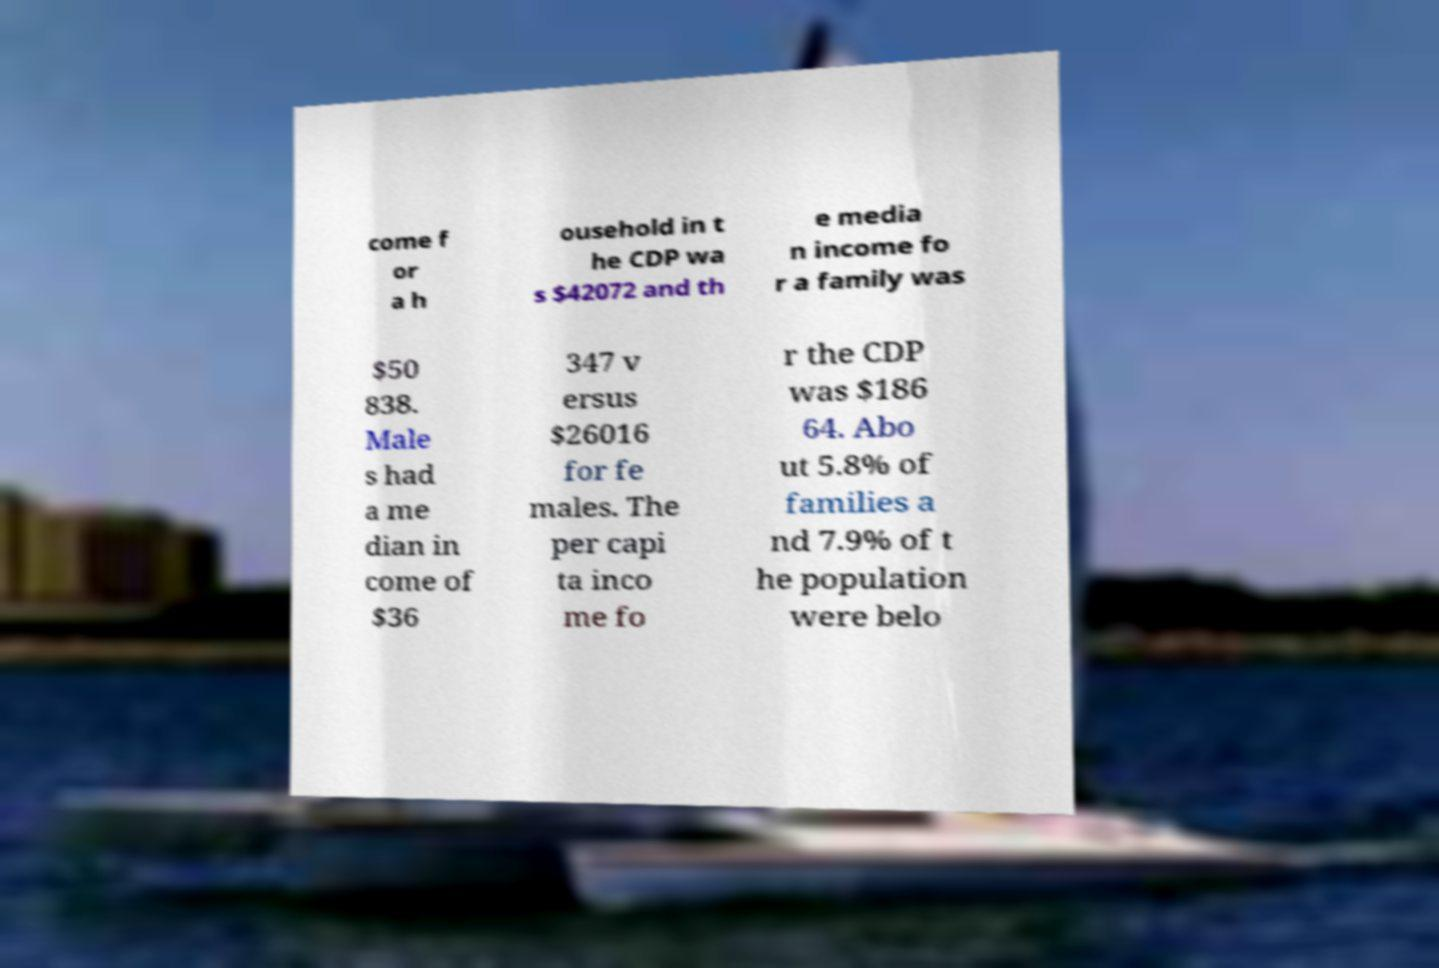What messages or text are displayed in this image? I need them in a readable, typed format. come f or a h ousehold in t he CDP wa s $42072 and th e media n income fo r a family was $50 838. Male s had a me dian in come of $36 347 v ersus $26016 for fe males. The per capi ta inco me fo r the CDP was $186 64. Abo ut 5.8% of families a nd 7.9% of t he population were belo 